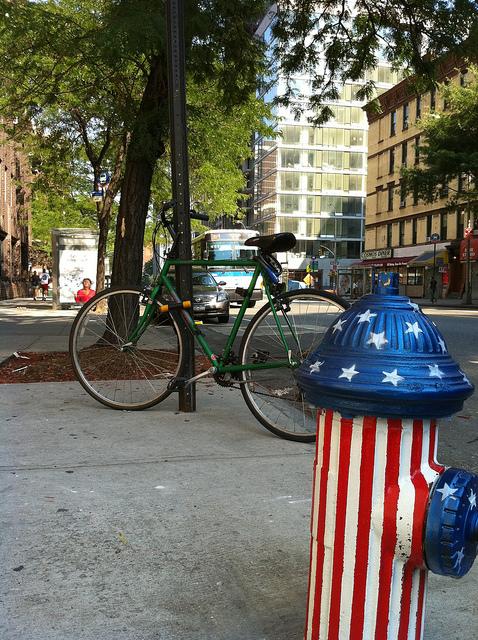What color is the fire hydrant?
Quick response, please. Red, white, blue. Why is the bike connected to the pole?
Give a very brief answer. Prevent theft. Who painted the water pump?
Keep it brief. City. 